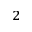Convert formula to latex. <formula><loc_0><loc_0><loc_500><loc_500>^ { 2 }</formula> 